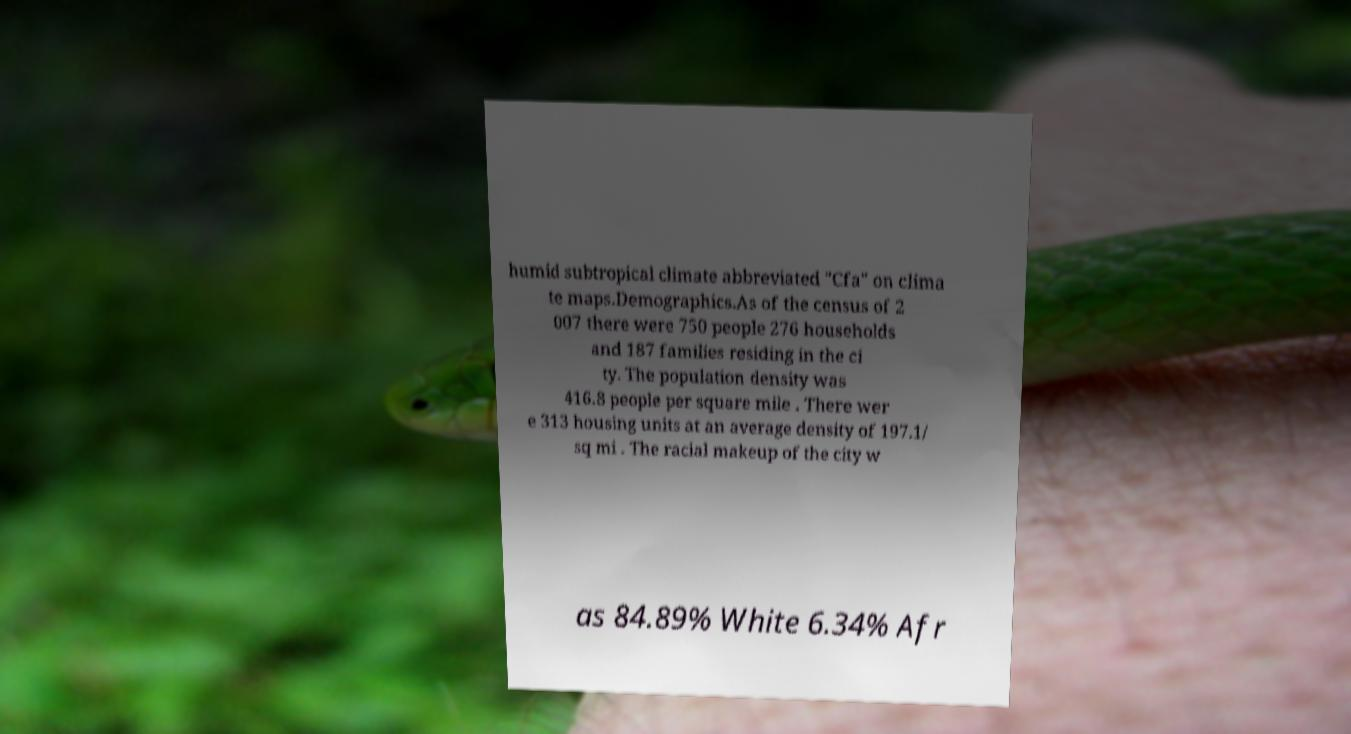Please read and relay the text visible in this image. What does it say? humid subtropical climate abbreviated "Cfa" on clima te maps.Demographics.As of the census of 2 007 there were 750 people 276 households and 187 families residing in the ci ty. The population density was 416.8 people per square mile . There wer e 313 housing units at an average density of 197.1/ sq mi . The racial makeup of the city w as 84.89% White 6.34% Afr 